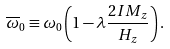<formula> <loc_0><loc_0><loc_500><loc_500>\overline { \omega } _ { 0 } \equiv \omega _ { 0 } \left ( 1 - { \lambda } \frac { 2 I M _ { z } } { H _ { z } } \right ) .</formula> 